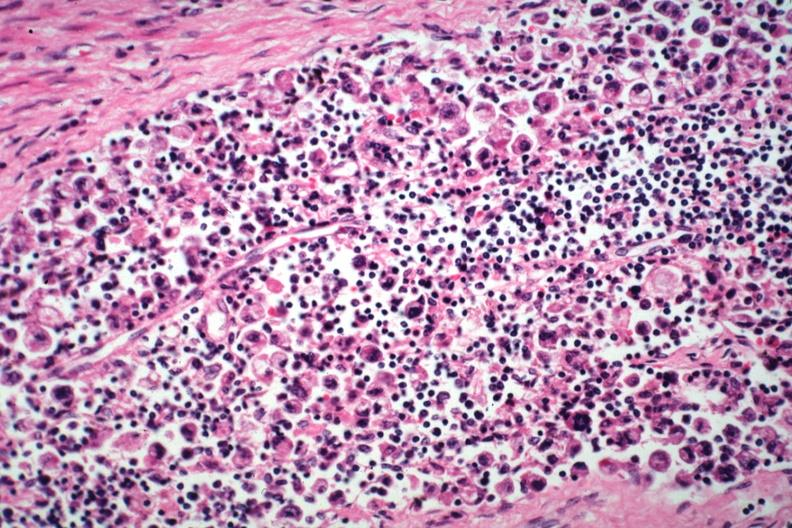s incidental finding died with promyelocytic leukemia stomach lesion #?
Answer the question using a single word or phrase. Yes 